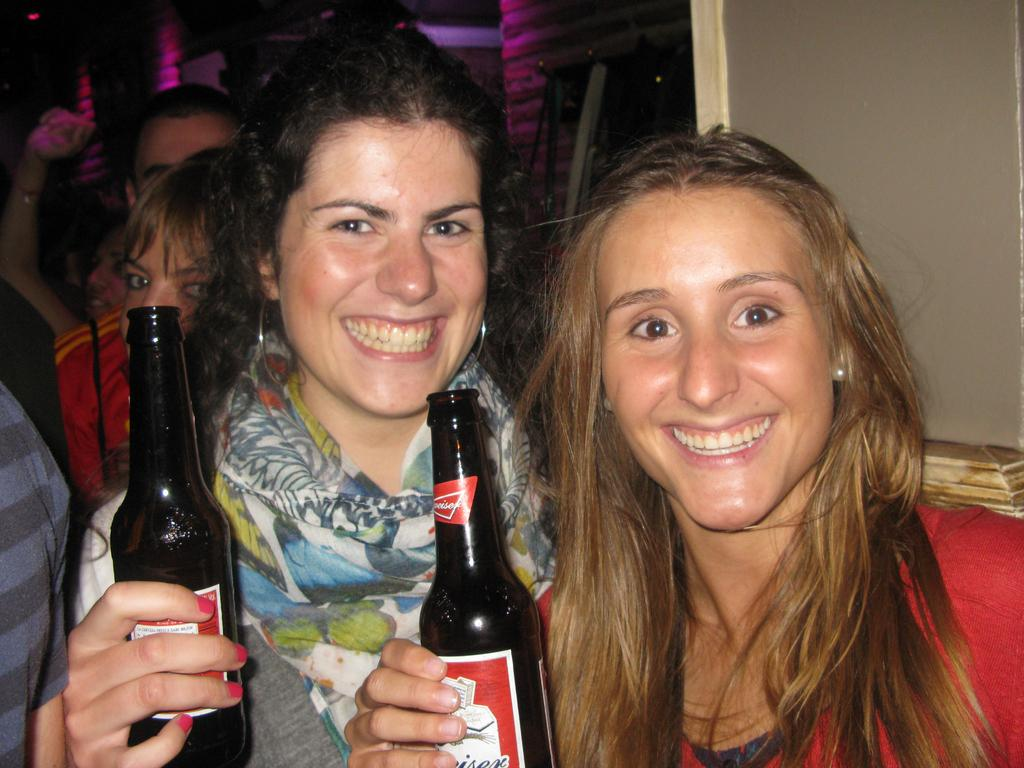How many ladies are in the image? There are two ladies in the image. What are the ladies holding in the image? The ladies are holding bottles in the image. What is the facial expression of the ladies? The ladies are smiling in the image. Can you describe the attire of the middle lady? The middle lady is wearing a scarf in the image. What can be seen in the background of the image? There are many persons in the background of the image. What type of badge is the middle lady wearing in the image? There is no badge visible on the middle lady in the image. How many horses are present in the image? There are no horses present in the image. 